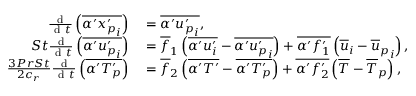Convert formula to latex. <formula><loc_0><loc_0><loc_500><loc_500>\begin{array} { r l } { \frac { d } { d t } \left ( \overline { { \alpha ^ { \prime } { x _ { p } ^ { \prime } } _ { i } } } \right ) } & = \overline { { \alpha ^ { \prime } { u _ { p } ^ { \prime } } _ { i } } } , } \\ { S t \frac { d } { d t } \left ( \overline { { \alpha ^ { \prime } { u _ { p } ^ { \prime } } _ { i } } } \right ) } & = \overline { f } _ { 1 } \left ( \overline { { \alpha ^ { \prime } u _ { i } ^ { \prime } } } - \overline { { \alpha ^ { \prime } { u _ { p } ^ { \prime } } _ { i } } } \right ) + \overline { { \alpha ^ { \prime } f _ { 1 } ^ { \prime } } } \left ( \overline { u } _ { i } - { \overline { u } _ { p } } _ { i } \right ) , } \\ { \frac { 3 P r S t } { 2 c _ { r } } \frac { d } { d t } \left ( \overline { { \alpha ^ { \prime } { T _ { p } ^ { \prime } } } } \right ) } & = \overline { f } _ { 2 } \left ( \overline { { \alpha ^ { \prime } T ^ { \prime } } } - \overline { { \alpha ^ { \prime } { T _ { p } ^ { \prime } } } } \right ) + \overline { { \alpha ^ { \prime } f _ { 2 } ^ { \prime } } } \left ( \overline { T } - { \overline { T } _ { p } } \right ) , } \end{array}</formula> 